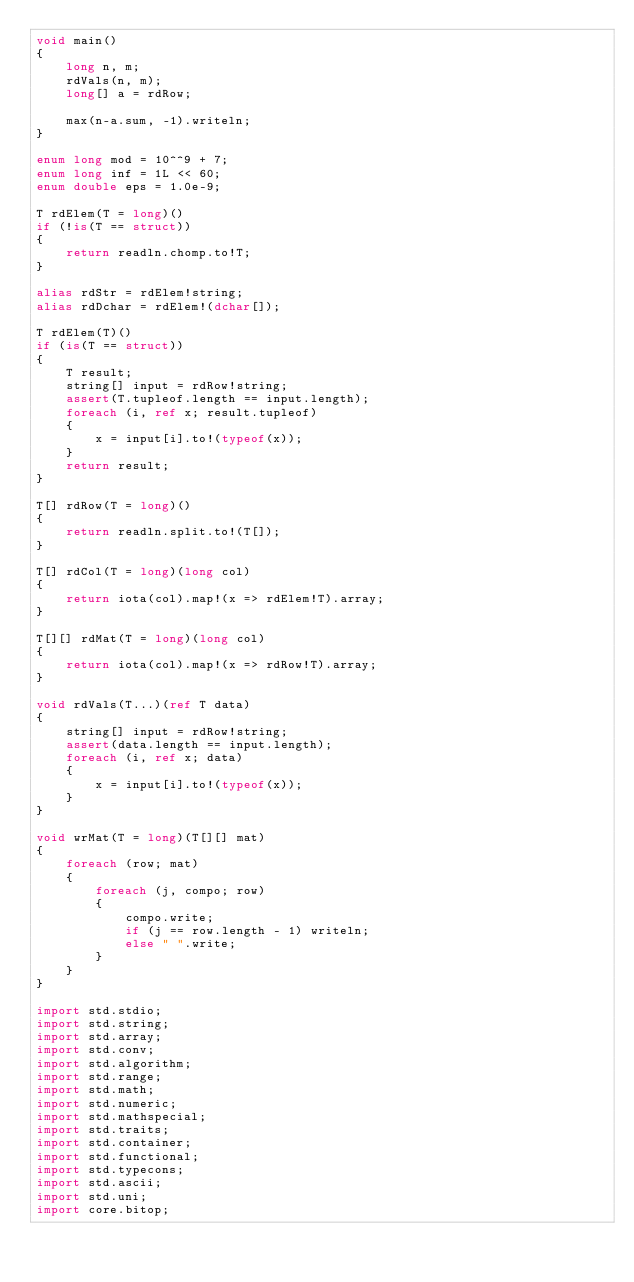<code> <loc_0><loc_0><loc_500><loc_500><_D_>void main()
{
    long n, m;
    rdVals(n, m);
    long[] a = rdRow;

    max(n-a.sum, -1).writeln;
}

enum long mod = 10^^9 + 7;
enum long inf = 1L << 60;
enum double eps = 1.0e-9;

T rdElem(T = long)()
if (!is(T == struct))
{
    return readln.chomp.to!T;
}

alias rdStr = rdElem!string;
alias rdDchar = rdElem!(dchar[]);

T rdElem(T)()
if (is(T == struct))
{
    T result;
    string[] input = rdRow!string;
    assert(T.tupleof.length == input.length);
    foreach (i, ref x; result.tupleof)
    {
        x = input[i].to!(typeof(x));
    }
    return result;
}

T[] rdRow(T = long)()
{
    return readln.split.to!(T[]);
}

T[] rdCol(T = long)(long col)
{
    return iota(col).map!(x => rdElem!T).array;
}

T[][] rdMat(T = long)(long col)
{
    return iota(col).map!(x => rdRow!T).array;
}

void rdVals(T...)(ref T data)
{
    string[] input = rdRow!string;
    assert(data.length == input.length);
    foreach (i, ref x; data)
    {
        x = input[i].to!(typeof(x));
    }
}

void wrMat(T = long)(T[][] mat)
{
    foreach (row; mat)
    {
        foreach (j, compo; row)
        {
            compo.write;
            if (j == row.length - 1) writeln;
            else " ".write;
        }
    }
}

import std.stdio;
import std.string;
import std.array;
import std.conv;
import std.algorithm;
import std.range;
import std.math;
import std.numeric;
import std.mathspecial;
import std.traits;
import std.container;
import std.functional;
import std.typecons;
import std.ascii;
import std.uni;
import core.bitop;</code> 